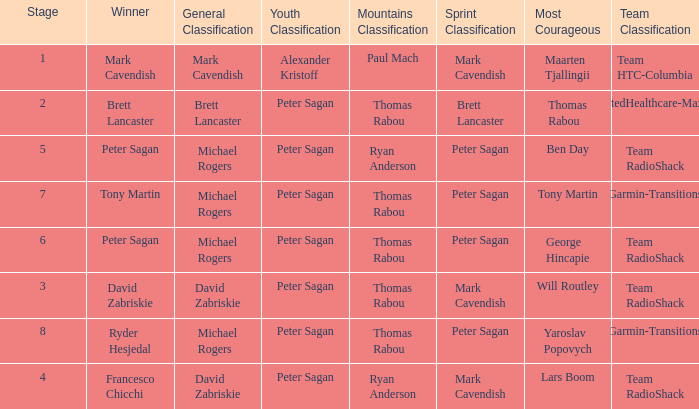When Brett Lancaster won the general classification, who won the team calssification? UnitedHealthcare-Maxxis. 